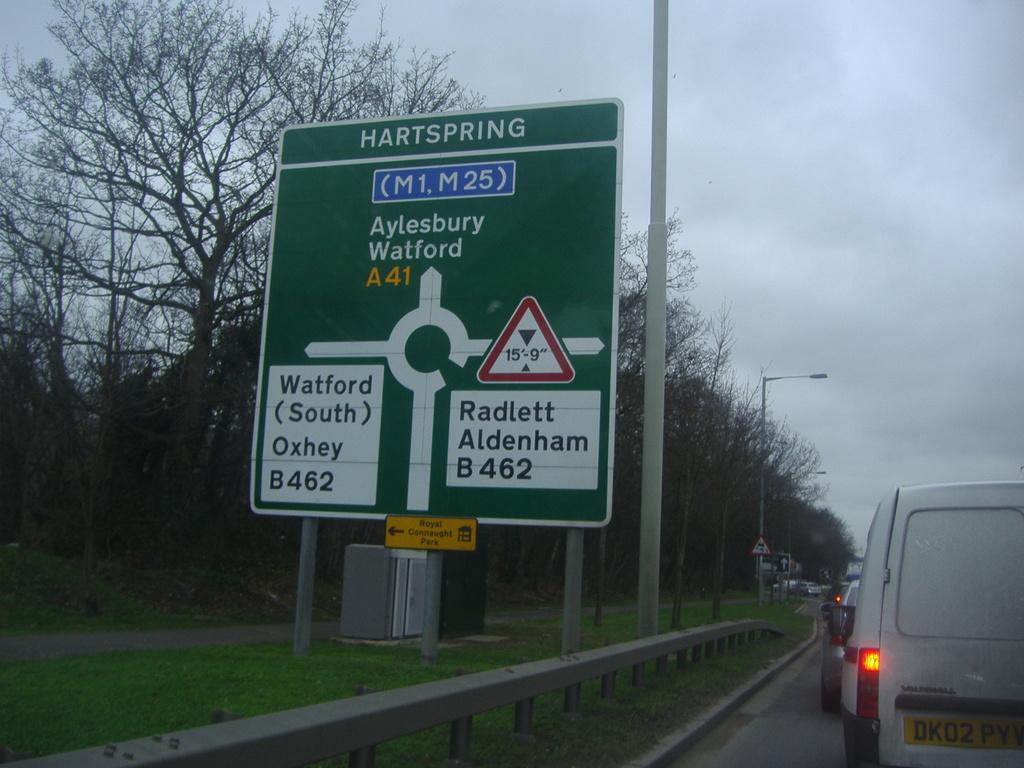What does the license plate say?
Your answer should be compact. Dk02pyv. What is the city at the top of the green sign?
Your response must be concise. Hartspring. 